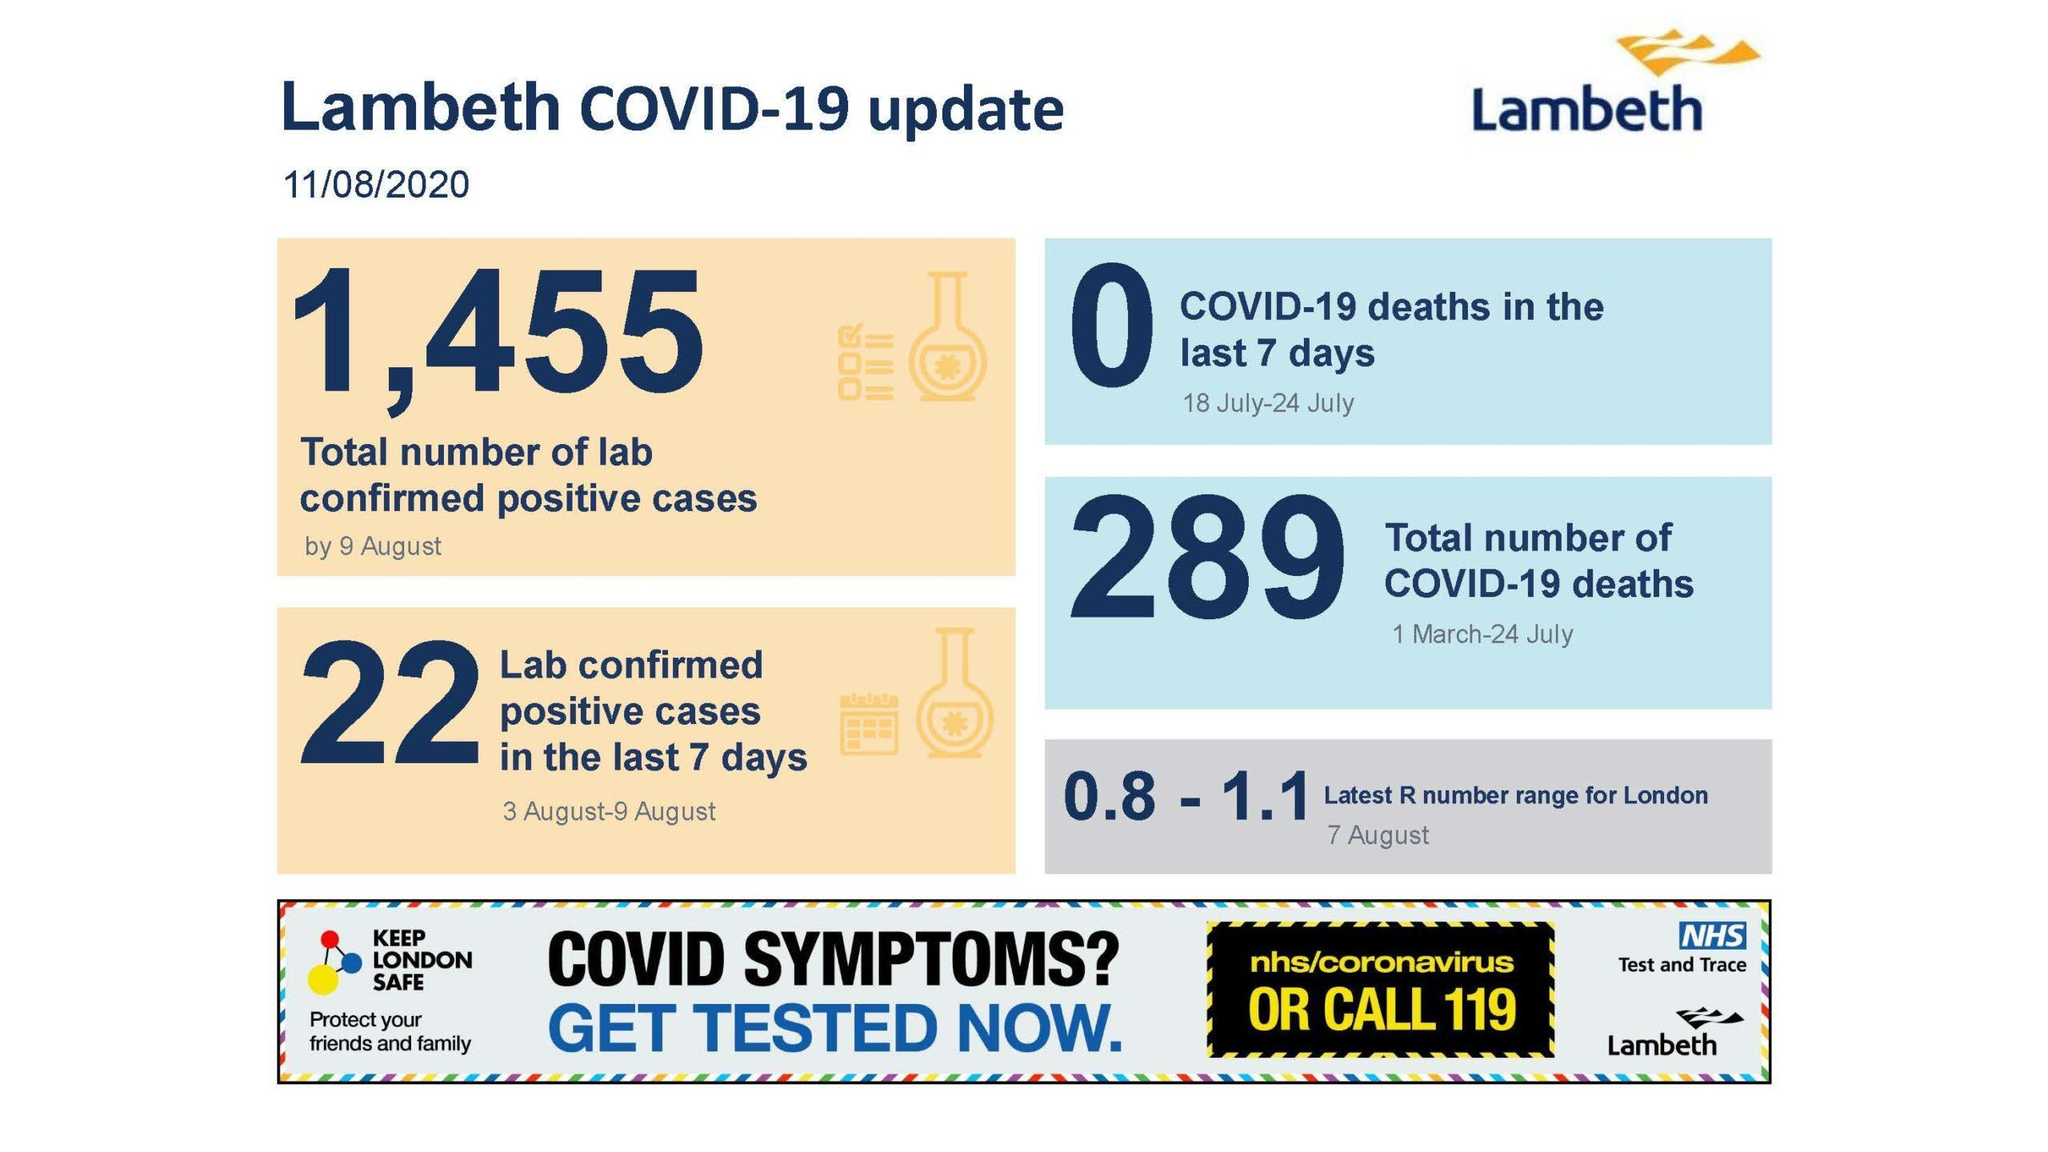On which date Latest R number range is taken?
Answer the question with a short phrase. 7 August How many Corona confirmed patients lost their lives previous week? 0 How many people lost their lives on March 1- July 24? 289 How many Laboratories verified corona in the previous week? 22 What is the overall count of laboratories which confirmed corona cases on August 9? 1,455 